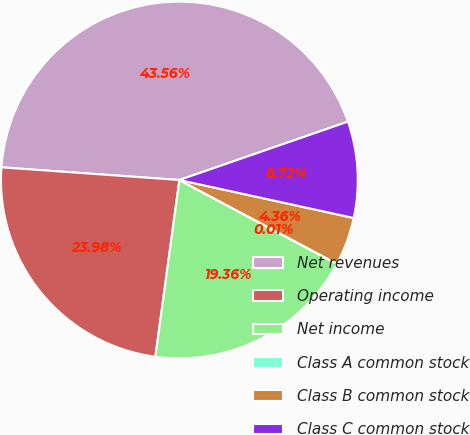<chart> <loc_0><loc_0><loc_500><loc_500><pie_chart><fcel>Net revenues<fcel>Operating income<fcel>Net income<fcel>Class A common stock<fcel>Class B common stock<fcel>Class C common stock<nl><fcel>43.56%<fcel>23.98%<fcel>19.36%<fcel>0.01%<fcel>4.36%<fcel>8.72%<nl></chart> 